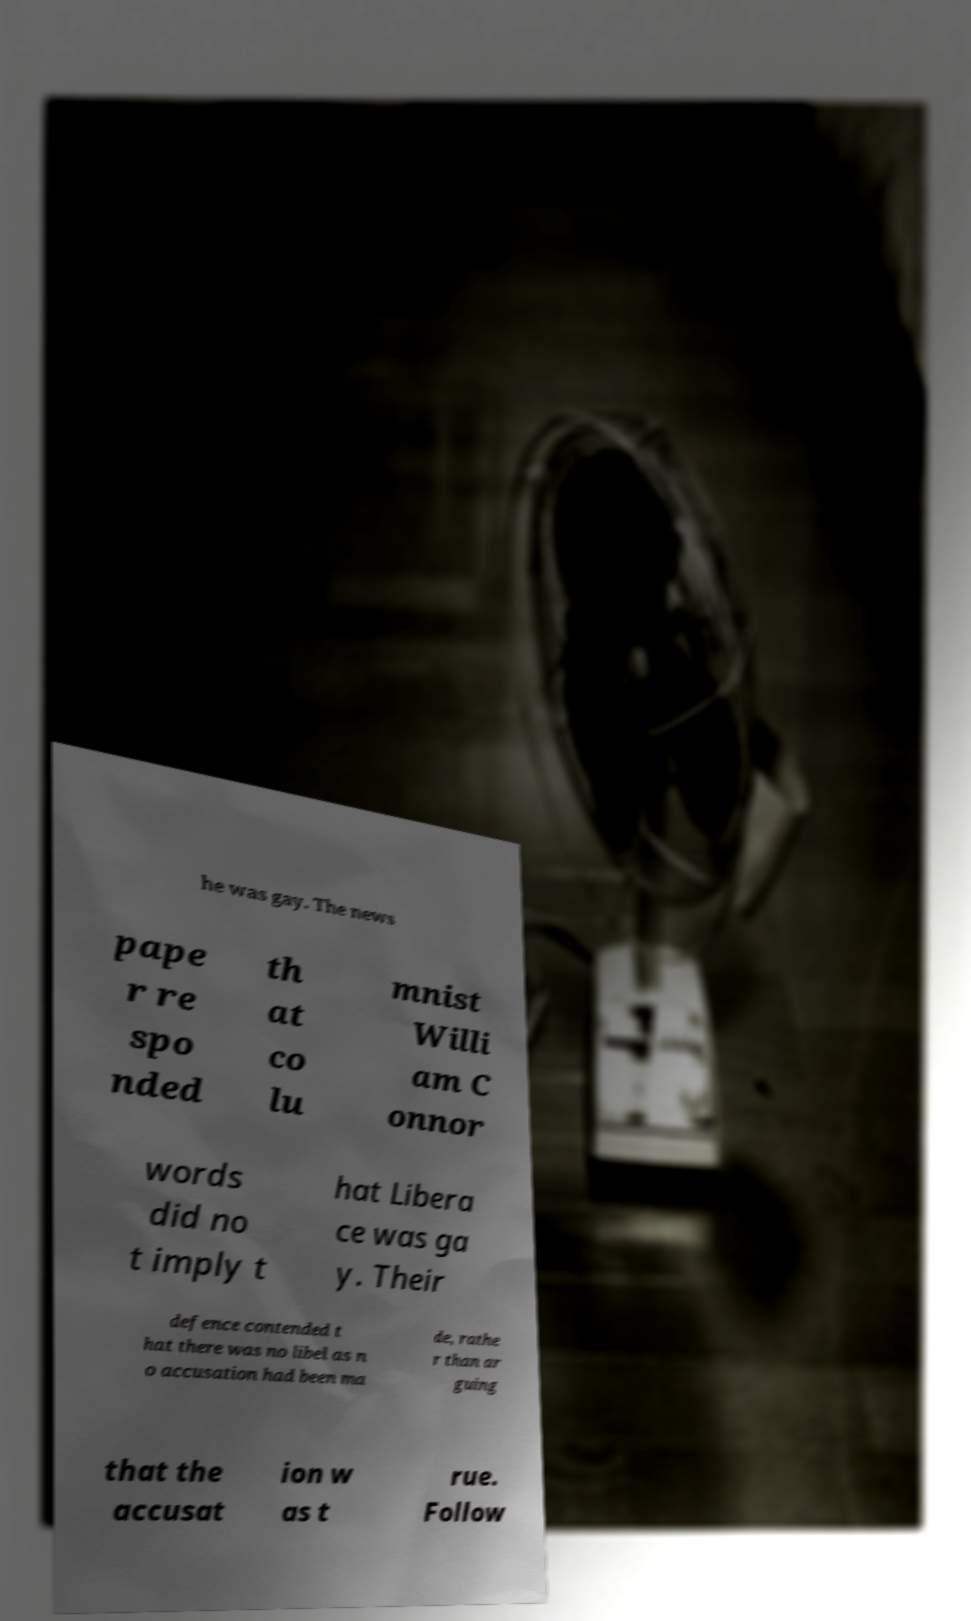Please identify and transcribe the text found in this image. he was gay. The news pape r re spo nded th at co lu mnist Willi am C onnor words did no t imply t hat Libera ce was ga y. Their defence contended t hat there was no libel as n o accusation had been ma de, rathe r than ar guing that the accusat ion w as t rue. Follow 